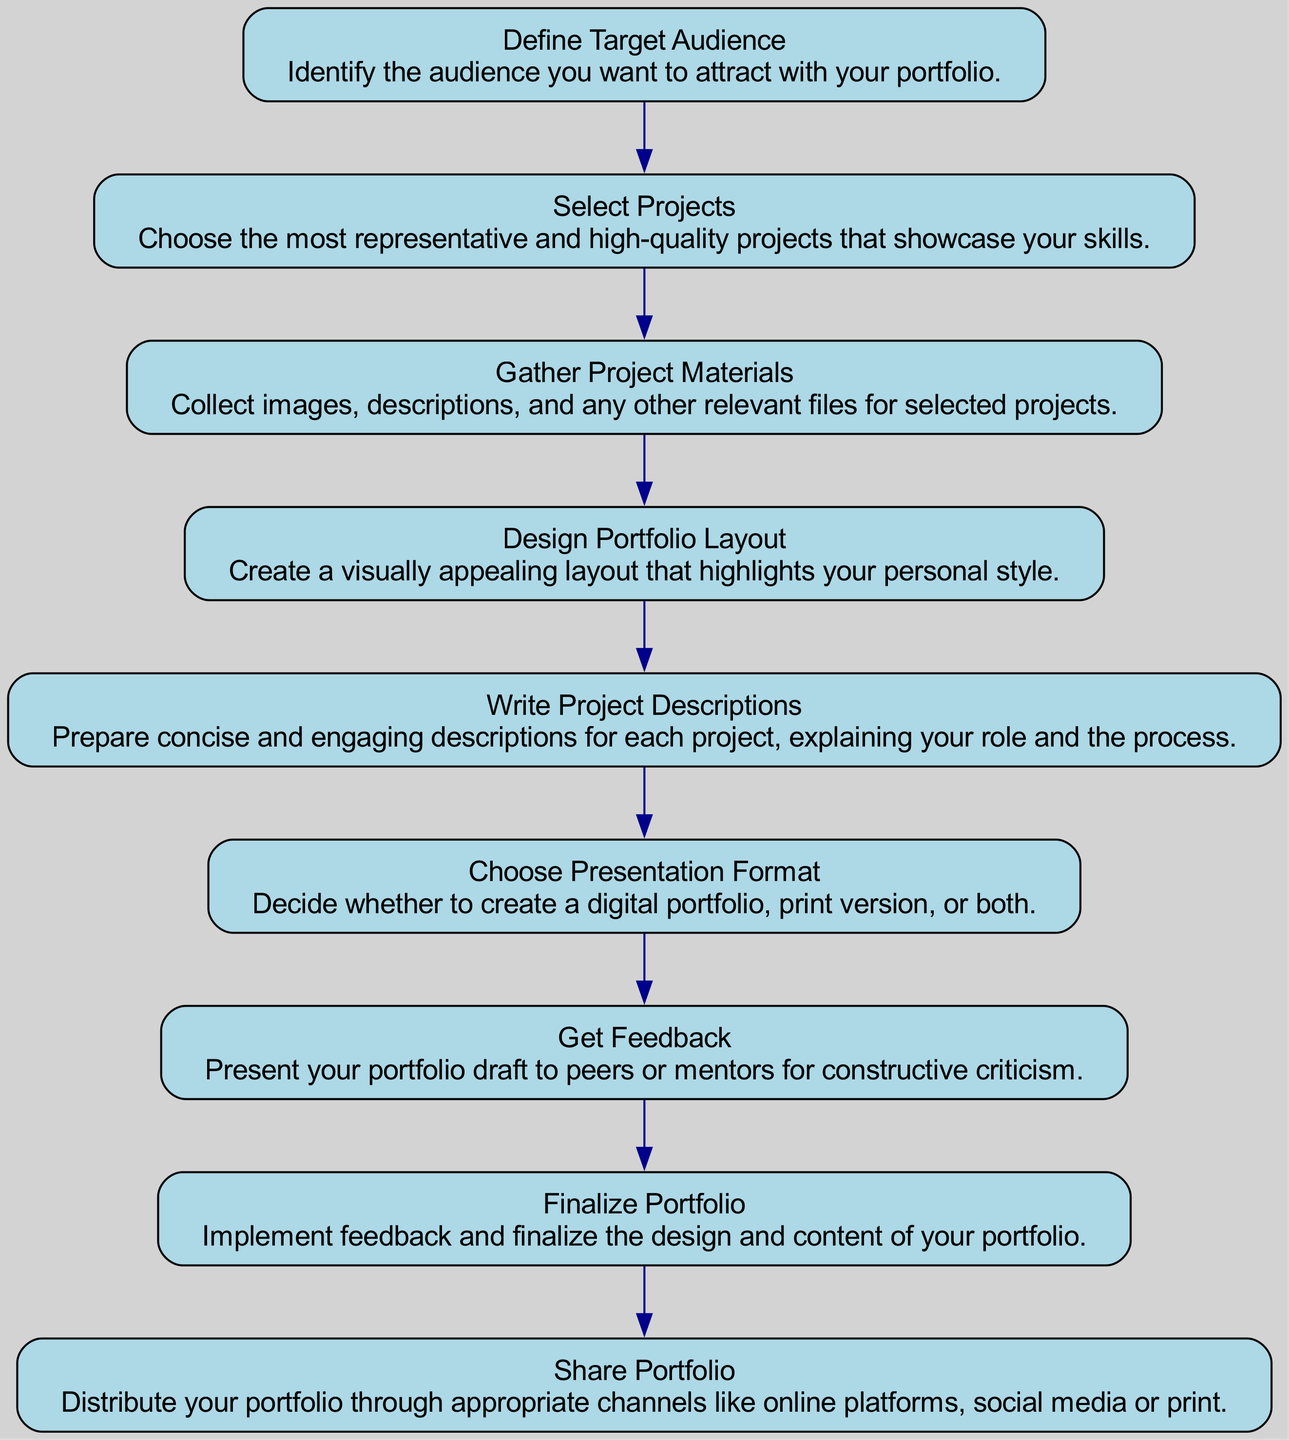What is the first step in creating a portfolio? The first step is labeled as "Define Target Audience" in the diagram. This is indicated as the topmost node in the flow chart and does not have any incoming edges, signifying that it initiates the workflow.
Answer: Define Target Audience How many main steps are shown in the diagram? The diagram contains a total of nine different steps, as observed from the number of nodes listed in the flow chart. Each step corresponds to a distinct phase in the portfolio creation process.
Answer: Nine What comes after selecting projects? The next step following "Select Projects" is "Gather Project Materials." This can be determined by following the connecting edge from the "Select Projects" node down to the subsequent node.
Answer: Gather Project Materials Which step involves active participation from others? The step that involves feedback from others is "Get Feedback," as indicated in the description of that node. It specifies the act of presenting the portfolio draft to peers or mentors, highlighting collaboration in the design process.
Answer: Get Feedback What type of portfolio can be decided upon during the creation process? The type of portfolio that can be decided is either "digital" or "print." This is referenced in the step labeled "Choose Presentation Format," which clearly outlines the options available for the portfolio medium.
Answer: Digital or print Which nodes are directly connected to the "Choose Presentation Format" node? The nodes directly connected to "Choose Presentation Format" are "Design Portfolio Layout" as the previous node and "Get Feedback" as the subsequent one. This can be identified by looking at the edges connecting "Choose Presentation Format" to other nodes.
Answer: Design Portfolio Layout and Get Feedback What is the last step before distributing the portfolio? The final step before sharing the portfolio is "Finalize Portfolio." This node is positioned just before "Share Portfolio," indicating its role as the last preparation stage in the workflow.
Answer: Finalize Portfolio What is the primary activity in the "Write Project Descriptions" step? The main activity in "Write Project Descriptions" involves preparing concise and engaging explanations for each selected project. This can be derived from the description associated with that particular node in the flow.
Answer: Preparing descriptions In which step is the layout of the portfolio determined? The layout of the portfolio is determined in the "Design Portfolio Layout" step, as indicated by the name of the node and its position in the sequence of activities within the diagram.
Answer: Design Portfolio Layout 